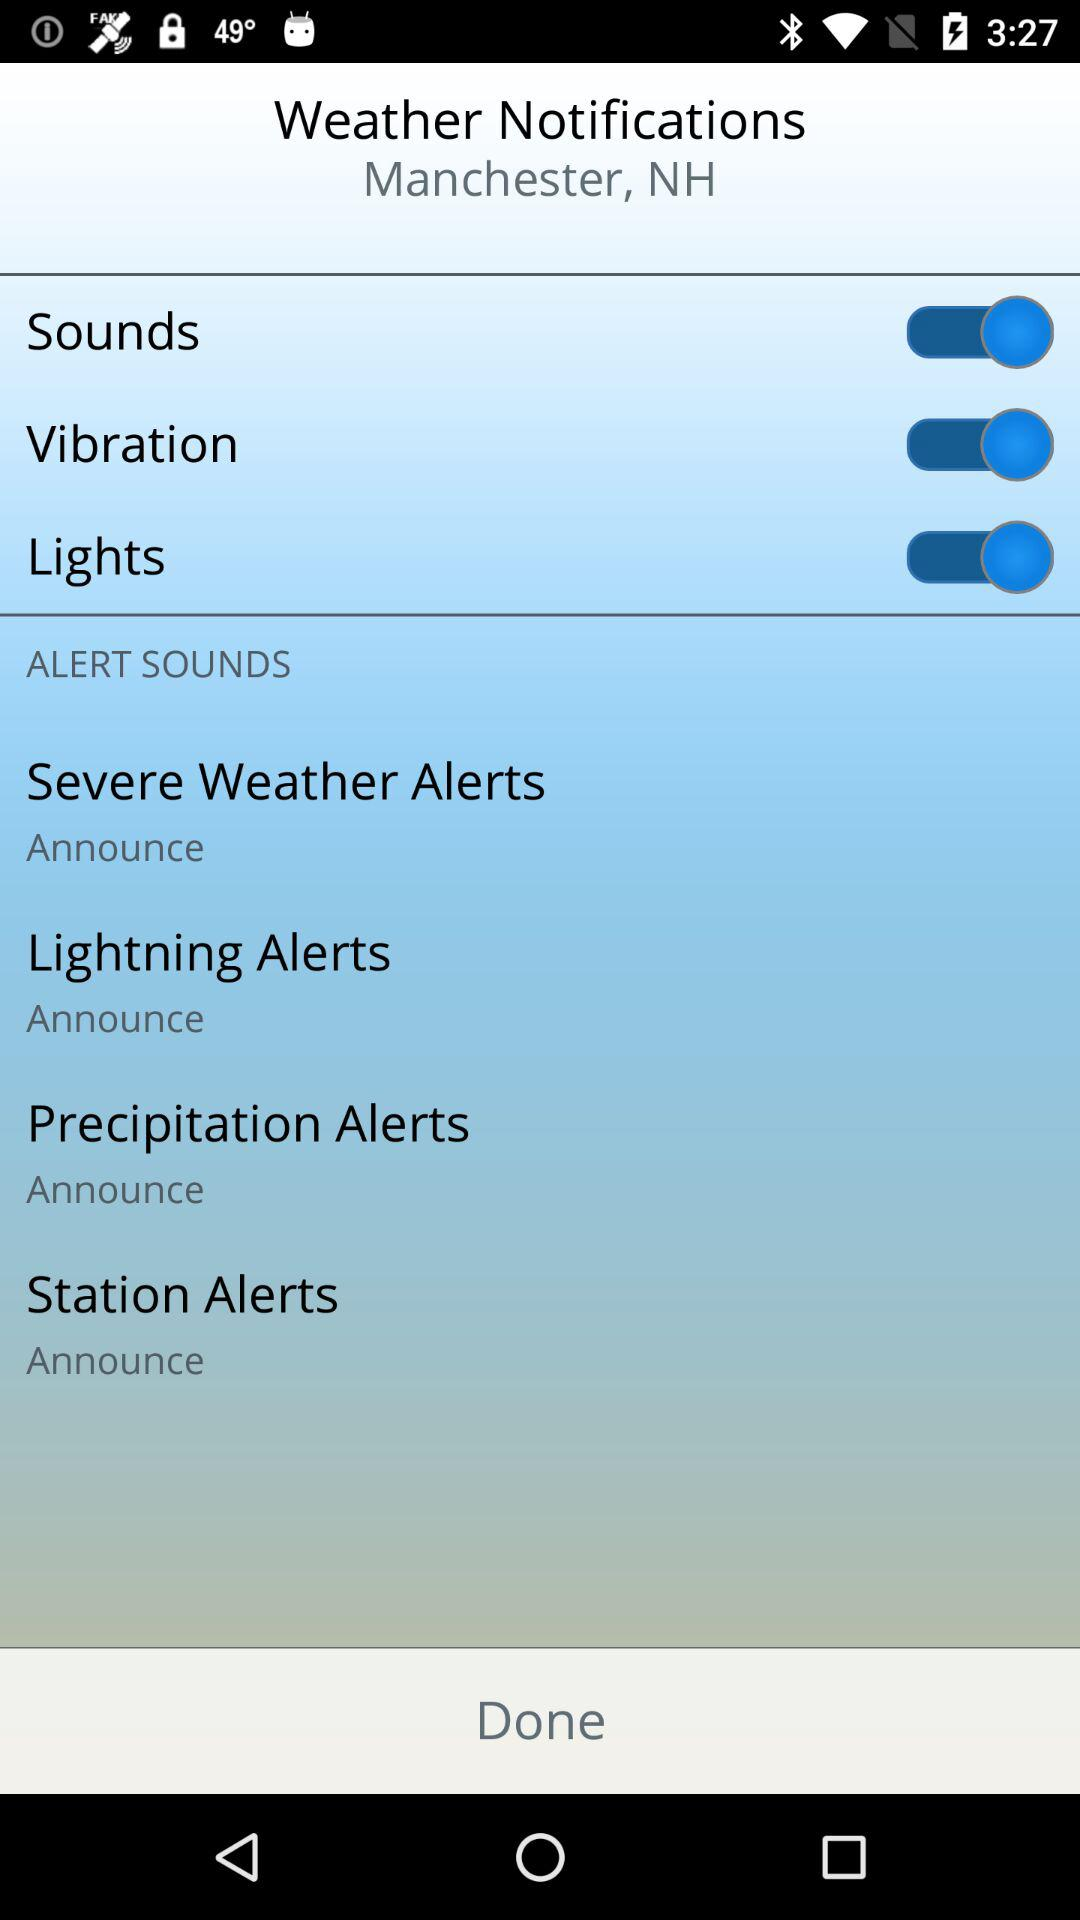How many alerts have the option to announce?
Answer the question using a single word or phrase. 4 